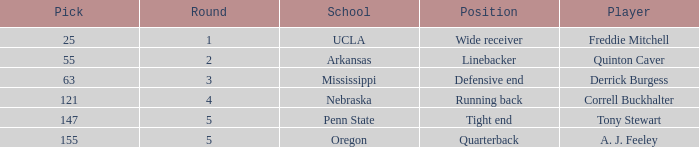Help me parse the entirety of this table. {'header': ['Pick', 'Round', 'School', 'Position', 'Player'], 'rows': [['25', '1', 'UCLA', 'Wide receiver', 'Freddie Mitchell'], ['55', '2', 'Arkansas', 'Linebacker', 'Quinton Caver'], ['63', '3', 'Mississippi', 'Defensive end', 'Derrick Burgess'], ['121', '4', 'Nebraska', 'Running back', 'Correll Buckhalter'], ['147', '5', 'Penn State', 'Tight end', 'Tony Stewart'], ['155', '5', 'Oregon', 'Quarterback', 'A. J. Feeley']]} In round 3, what role did the selected player perform? Defensive end. 